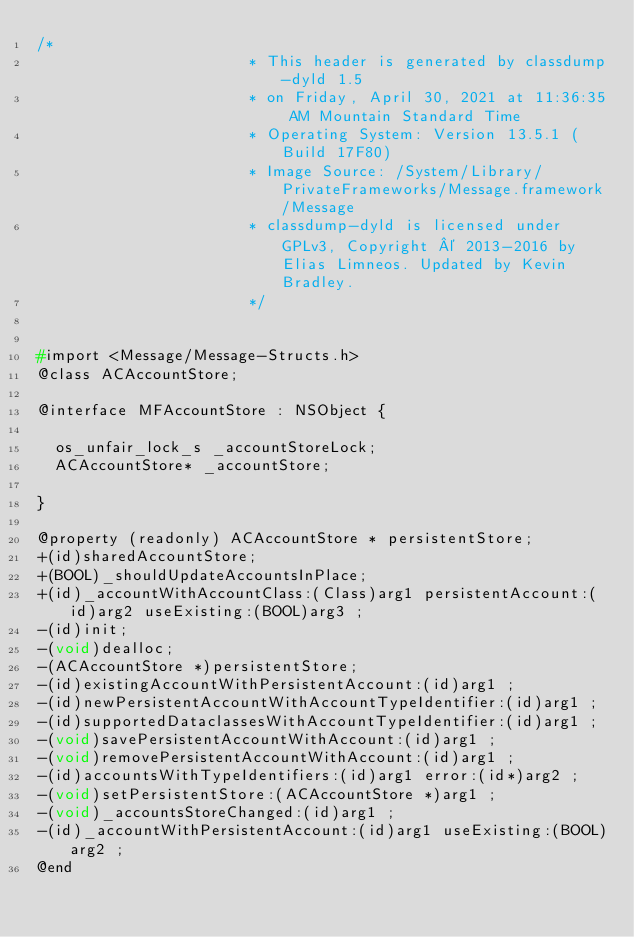Convert code to text. <code><loc_0><loc_0><loc_500><loc_500><_C_>/*
                       * This header is generated by classdump-dyld 1.5
                       * on Friday, April 30, 2021 at 11:36:35 AM Mountain Standard Time
                       * Operating System: Version 13.5.1 (Build 17F80)
                       * Image Source: /System/Library/PrivateFrameworks/Message.framework/Message
                       * classdump-dyld is licensed under GPLv3, Copyright © 2013-2016 by Elias Limneos. Updated by Kevin Bradley.
                       */


#import <Message/Message-Structs.h>
@class ACAccountStore;

@interface MFAccountStore : NSObject {

	os_unfair_lock_s _accountStoreLock;
	ACAccountStore* _accountStore;

}

@property (readonly) ACAccountStore * persistentStore; 
+(id)sharedAccountStore;
+(BOOL)_shouldUpdateAccountsInPlace;
+(id)_accountWithAccountClass:(Class)arg1 persistentAccount:(id)arg2 useExisting:(BOOL)arg3 ;
-(id)init;
-(void)dealloc;
-(ACAccountStore *)persistentStore;
-(id)existingAccountWithPersistentAccount:(id)arg1 ;
-(id)newPersistentAccountWithAccountTypeIdentifier:(id)arg1 ;
-(id)supportedDataclassesWithAccountTypeIdentifier:(id)arg1 ;
-(void)savePersistentAccountWithAccount:(id)arg1 ;
-(void)removePersistentAccountWithAccount:(id)arg1 ;
-(id)accountsWithTypeIdentifiers:(id)arg1 error:(id*)arg2 ;
-(void)setPersistentStore:(ACAccountStore *)arg1 ;
-(void)_accountsStoreChanged:(id)arg1 ;
-(id)_accountWithPersistentAccount:(id)arg1 useExisting:(BOOL)arg2 ;
@end

</code> 